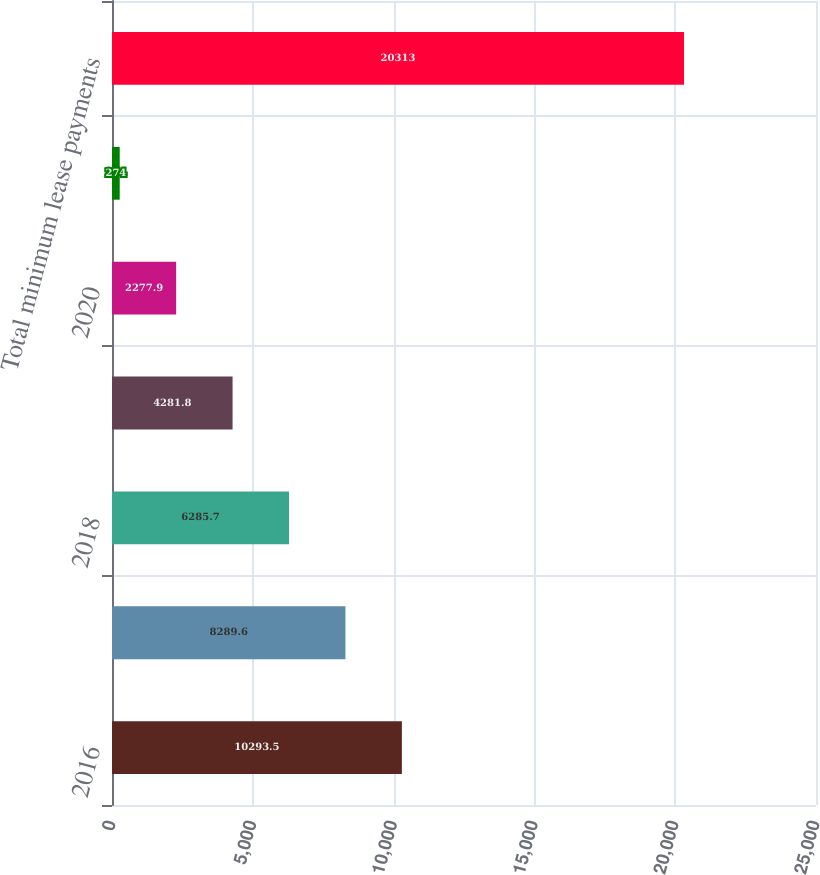Convert chart. <chart><loc_0><loc_0><loc_500><loc_500><bar_chart><fcel>2016<fcel>2017<fcel>2018<fcel>2019<fcel>2020<fcel>Thereafter<fcel>Total minimum lease payments<nl><fcel>10293.5<fcel>8289.6<fcel>6285.7<fcel>4281.8<fcel>2277.9<fcel>274<fcel>20313<nl></chart> 